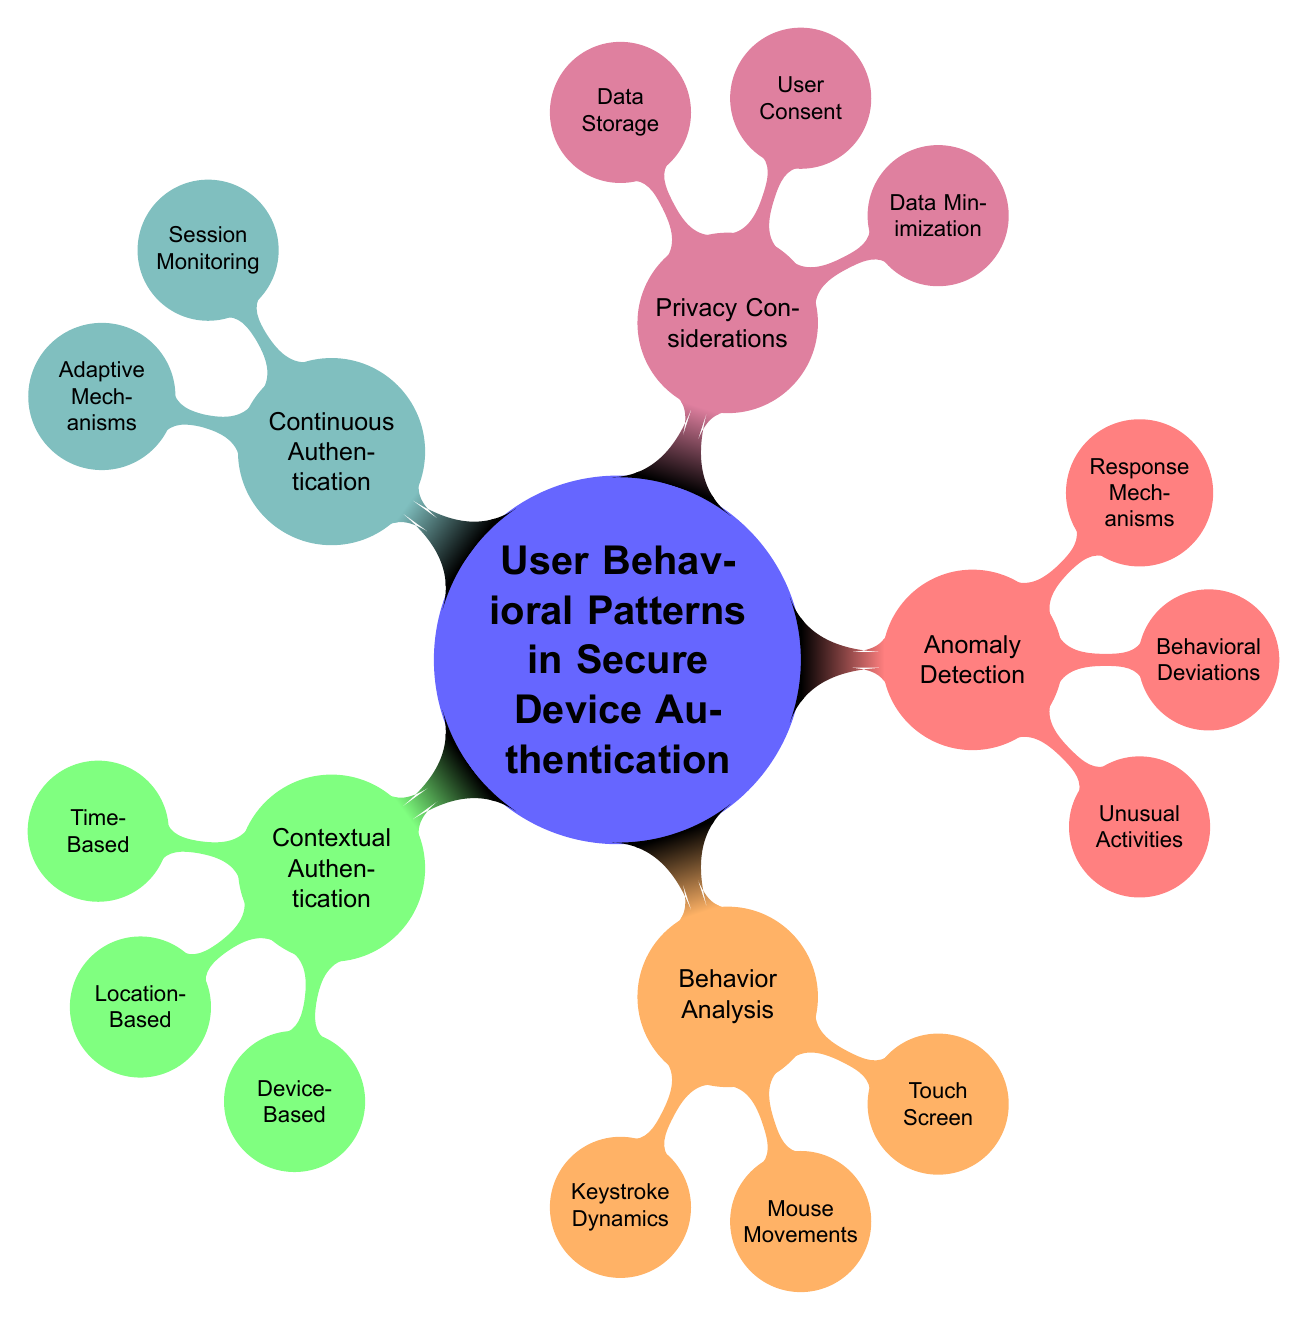What's the main topic of the mind map? The central node of the mind map states that the main topic is "User Behavioral Patterns in Secure Device Authentication".
Answer: User Behavioral Patterns in Secure Device Authentication How many main branches are there? The mind map has five main branches emanating from the central node, corresponding to different aspects of user behavior in device authentication.
Answer: 5 What are the three types of patterns under Contextual Authentication? Contextual Authentication has three subcategories: Time-Based Patterns, Location-Based Patterns, and Device-Based Patterns.
Answer: Time-Based, Location-Based, Device-Based What does the Response Mechanisms branch relate to in Anomaly Detection? The Response Mechanisms branch falls under the larger Anomaly Detection portion of the mind map, emphasizing how to react to anomalies detected during authentication.
Answer: Anomaly Detection Which branch discusses user consent? The branch "User Consent" is part of the "Privacy Considerations" category, focusing on aspects of obtaining consent from users regarding data use.
Answer: Privacy Considerations What is a key aspect of Continuous Authentication? A key aspect of Continuous Authentication is "Session Monitoring", which refers to continuously analyzing user behavior during a session.
Answer: Session Monitoring How are behavioral deviations identified in Anomaly Detection? Behavioral deviations are identified through patterns such as a change in typing speed and unexpected location during authentication attempts.
Answer: Change in typing speed, Unexpected location Which sub-nodes are part of Behavior Analysis? The Behavior Analysis branch includes Keystroke Dynamics, Mouse Movements, and Touch Screen Interactions as its sub-nodes.
Answer: Keystroke Dynamics, Mouse Movements, Touch Screen Interactions What is an example of Data Minimization in Privacy Considerations? An example of Data Minimization under Privacy Considerations is "Only essential data", which highlights the importance of limiting data usage.
Answer: Only essential data 